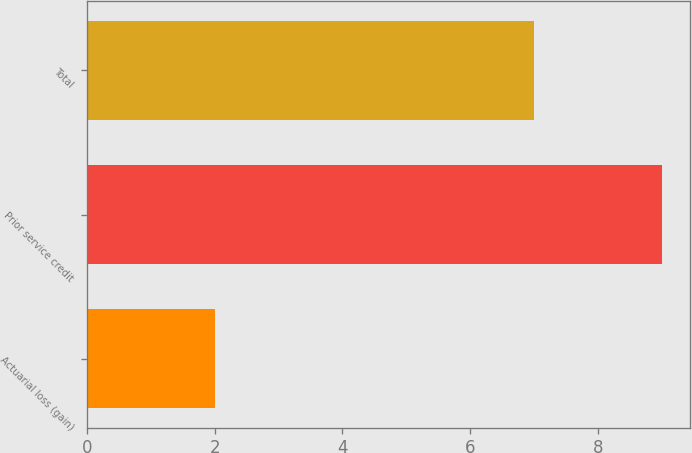Convert chart to OTSL. <chart><loc_0><loc_0><loc_500><loc_500><bar_chart><fcel>Actuarial loss (gain)<fcel>Prior service credit<fcel>Total<nl><fcel>2<fcel>9<fcel>7<nl></chart> 